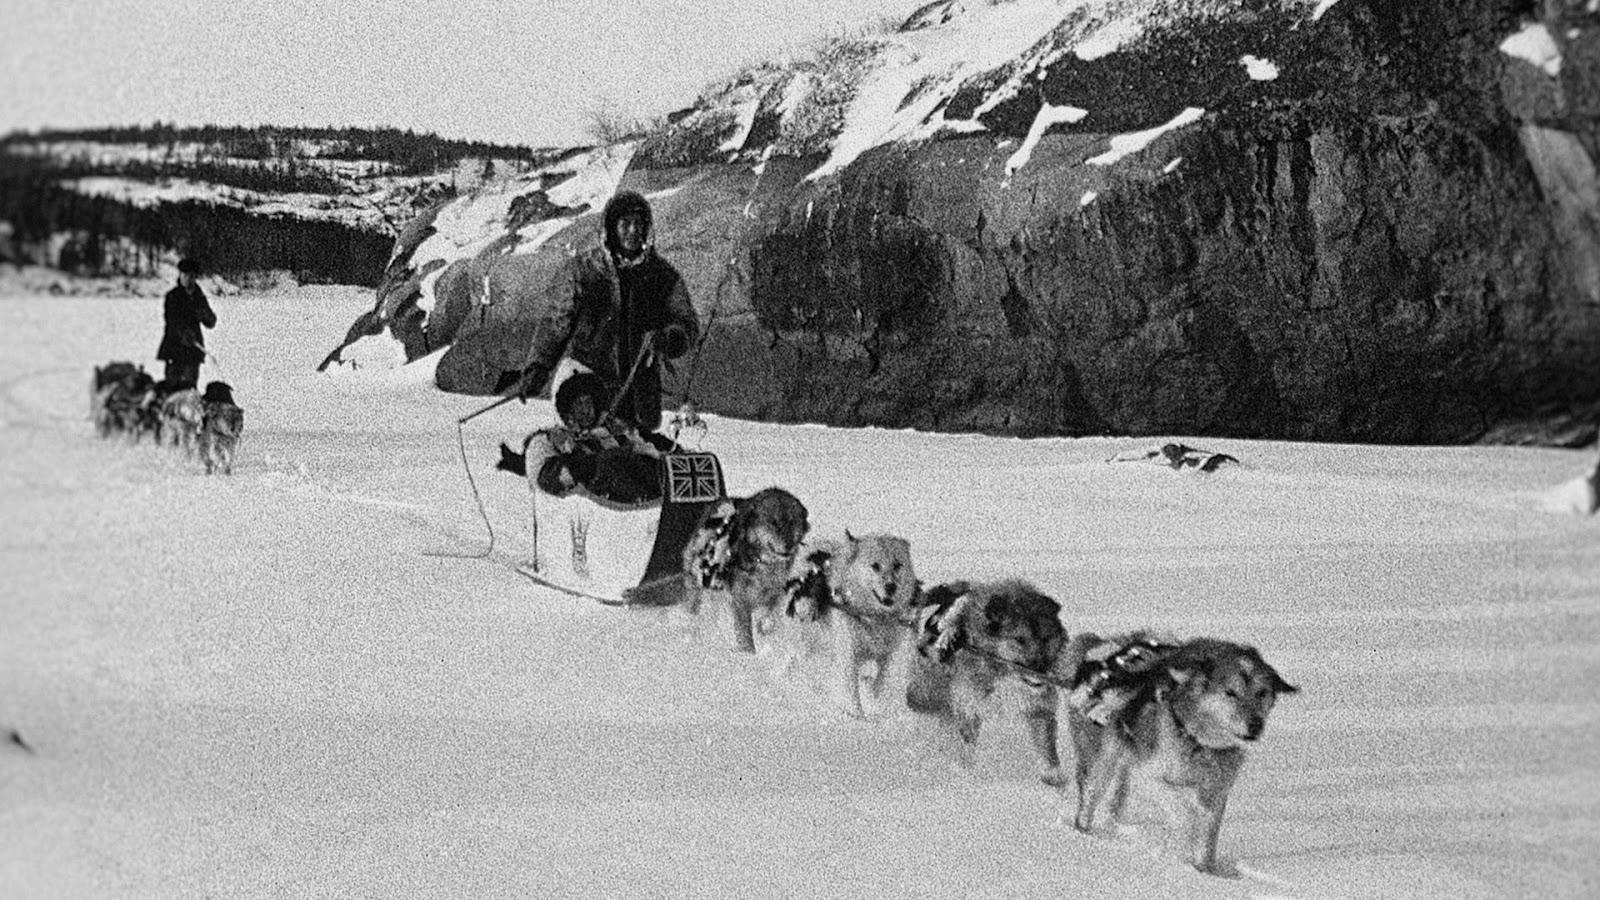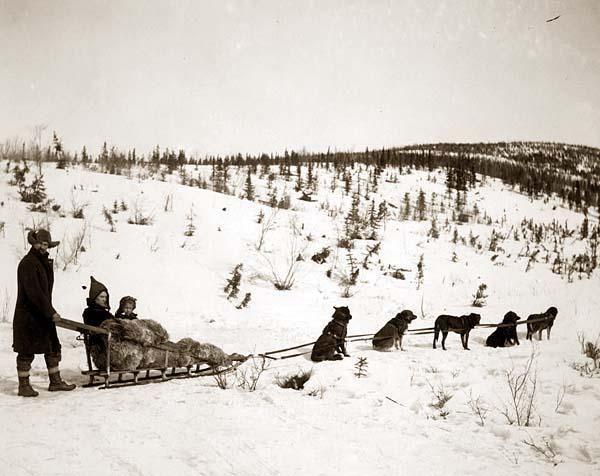The first image is the image on the left, the second image is the image on the right. Examine the images to the left and right. Is the description "One of the images contains no more than two dogs." accurate? Answer yes or no. No. 